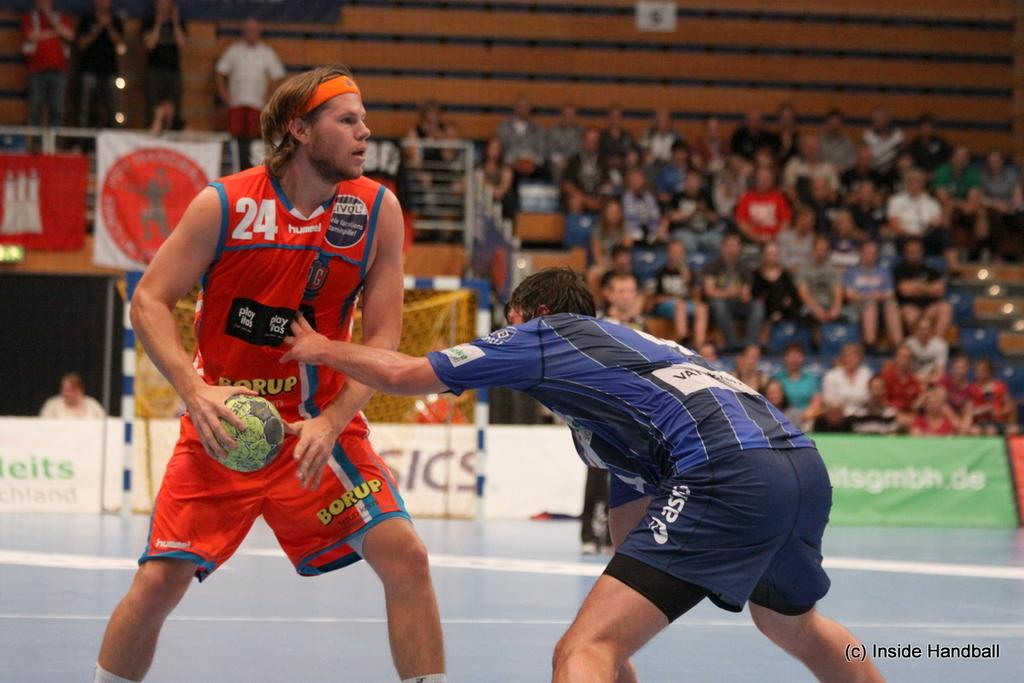<image>
Describe the image concisely. Player number 24 has the ball and looks for his teammates. 